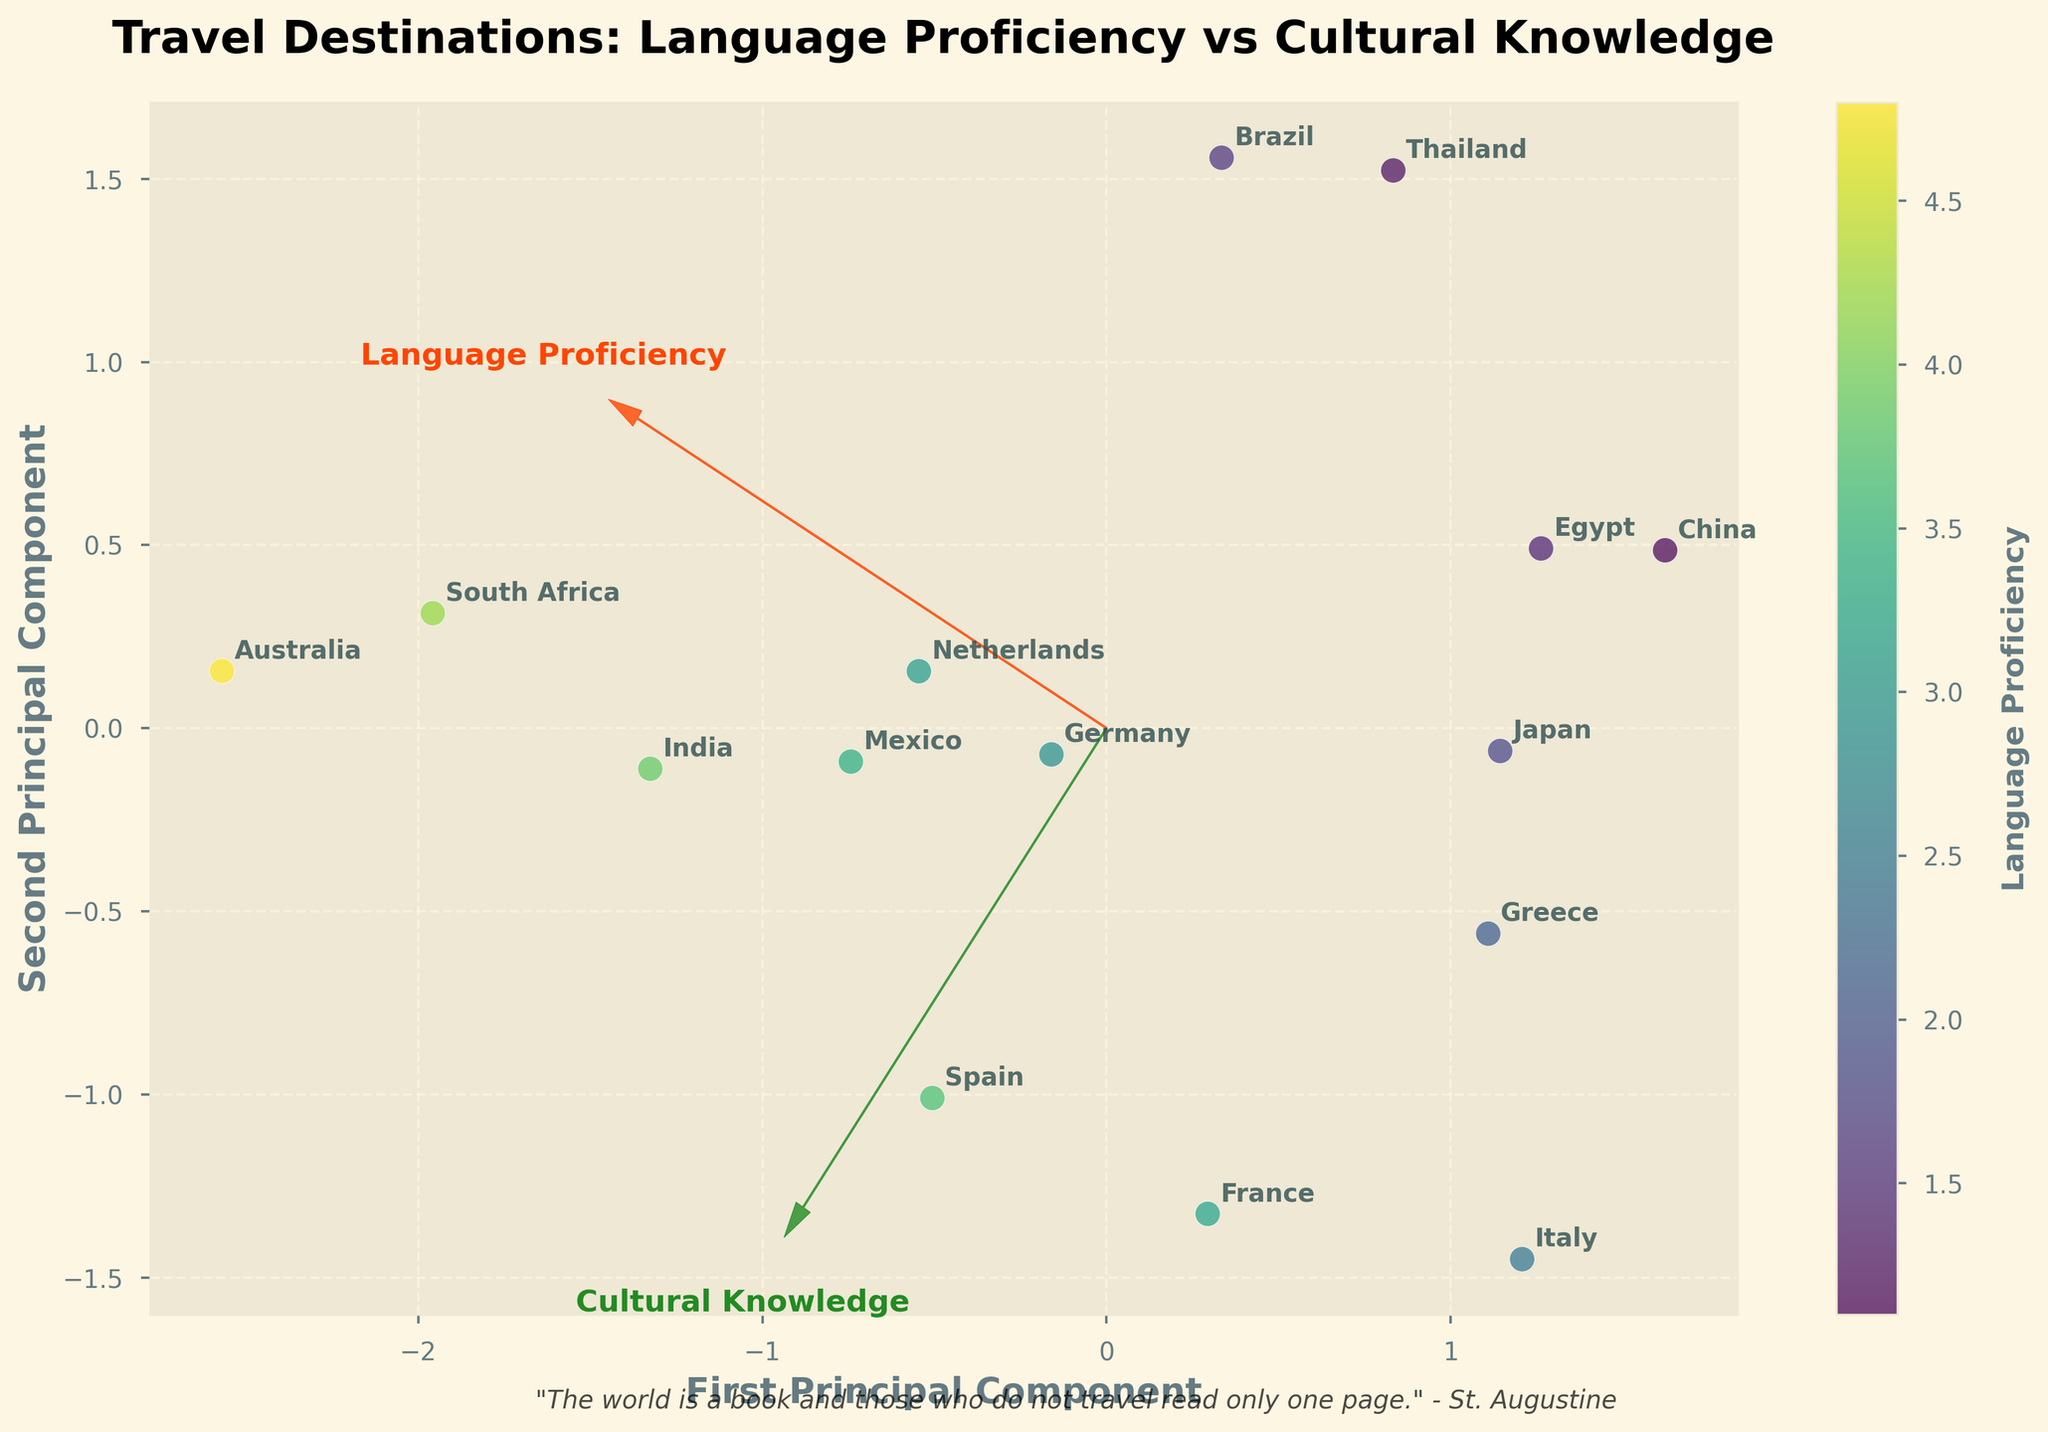What is the title of the plot? The title is typically written at the top of the plot. In this figure, you can see the title "Travel Destinations: Language Proficiency vs Cultural Knowledge".
Answer: Travel Destinations: Language Proficiency vs Cultural Knowledge How many countries are displayed in the biplot? You can determine the number of countries by counting the labeled data points. Each label represents a unique country, and there are 15 labeled points on the plot.
Answer: 15 Which country has the highest language proficiency? The color bar represents language proficiency, and the data point with the highest language proficiency would be the most brightly colored. Based on the plot, Australia has the highest language proficiency score at 4.8.
Answer: Australia Which country has the lowest cultural knowledge score? The y-axis represents cultural knowledge, so the country represented by the data point closest to the bottom of the plot has the lowest cultural knowledge. In this case, Australia has the lowest cultural knowledge score at 4.7.
Answer: Australia Which two countries are closest to each other in terms of both principal components? Look for the countries whose data points are nearest to each other. Spain and Japan's data points are quite close together on the plot, indicating similarity in character for both principal components.
Answer: Spain and Japan What does the feature vector for Language Proficiency indicate about the direction? The feature vector for Language Proficiency, represented as an arrow, points towards the right and slightly upward, indicating that higher language proficiency is generally associated with higher values along the first principal component.
Answer: Right and slightly upward How do the cultural knowledge scores vary with the first principal component? By observing the y-axis versus the direction of the first principal component, note that countries on the positive side of PC1 generally have higher cultural knowledge scores, as indicated by the arrow representing cultural knowledge.
Answer: Higher PC1 values often indicate higher cultural knowledge What can be inferred about the relationship between language proficiency and cultural knowledge from the biplot? The feature vectors are not perfectly aligned but have a positive angle suggesting a general positive correlation, but not a strong linear relationship, between language proficiency and cultural knowledge.
Answer: Positive but not strongly linear Is there any country with a high language proficiency but low cultural knowledge score? Look for a brightly colored data point that is lower on the y-axis. South Africa fits this criterion with a high language proficiency score (4.2) and lower cultural knowledge score (4.9).
Answer: South Africa Which countries are closer to the cultural knowledge vector but further from the language proficiency vector? Data points closer to the cultural knowledge arrow and far from the language proficiency arrow should be noted. Egypt and China lie relatively far from the language proficiency direction and closer to the cultural knowledge vector.
Answer: Egypt and China 